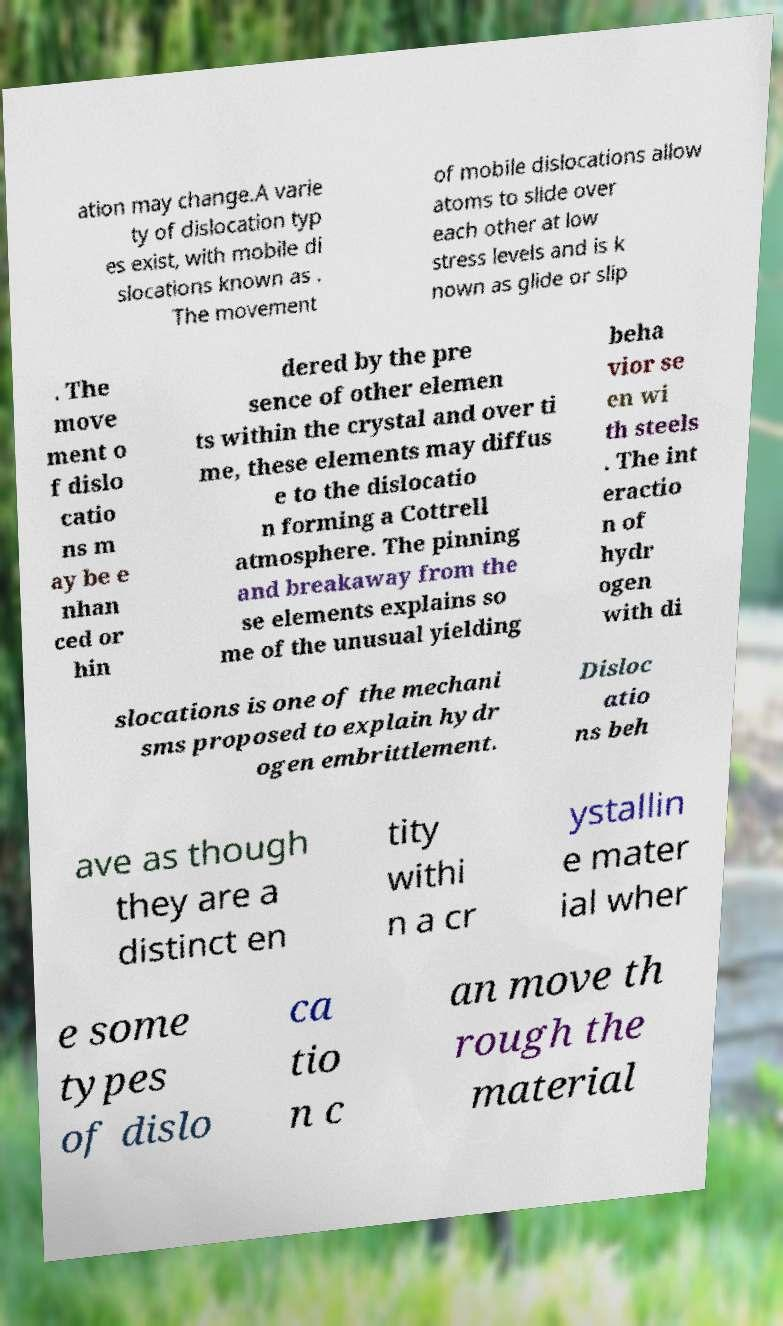Please read and relay the text visible in this image. What does it say? ation may change.A varie ty of dislocation typ es exist, with mobile di slocations known as . The movement of mobile dislocations allow atoms to slide over each other at low stress levels and is k nown as glide or slip . The move ment o f dislo catio ns m ay be e nhan ced or hin dered by the pre sence of other elemen ts within the crystal and over ti me, these elements may diffus e to the dislocatio n forming a Cottrell atmosphere. The pinning and breakaway from the se elements explains so me of the unusual yielding beha vior se en wi th steels . The int eractio n of hydr ogen with di slocations is one of the mechani sms proposed to explain hydr ogen embrittlement. Disloc atio ns beh ave as though they are a distinct en tity withi n a cr ystallin e mater ial wher e some types of dislo ca tio n c an move th rough the material 